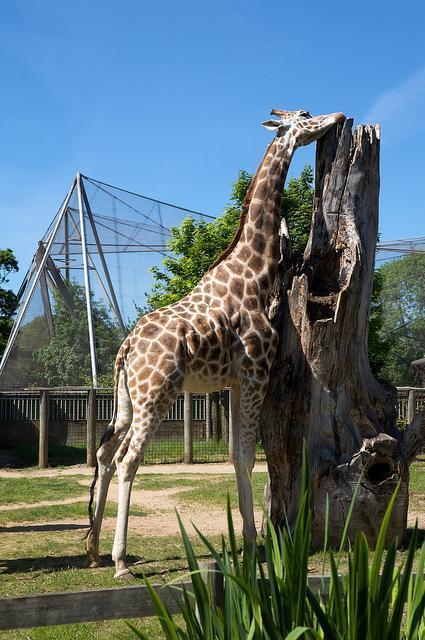How many giraffe's are eating?
Give a very brief answer. 1. 